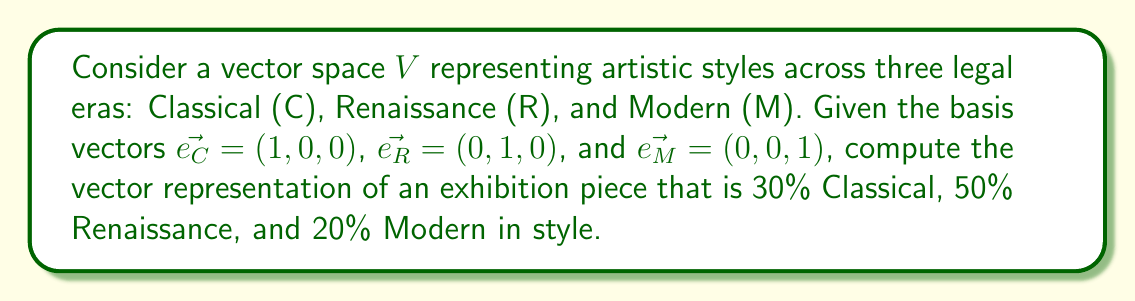Provide a solution to this math problem. To solve this problem, we'll follow these steps:

1) First, recall that in a vector space, we can represent any vector as a linear combination of basis vectors. In this case, our basis vectors are:

   $\vec{e_C} = (1,0,0)$ for Classical
   $\vec{e_R} = (0,1,0)$ for Renaissance
   $\vec{e_M} = (0,0,1)$ for Modern

2) The exhibition piece is described as being 30% Classical, 50% Renaissance, and 20% Modern. We can represent these percentages as scalar coefficients:

   Classical: 0.3
   Renaissance: 0.5
   Modern: 0.2

3) Now, we can form the linear combination:

   $\vec{v} = 0.3\vec{e_C} + 0.5\vec{e_R} + 0.2\vec{e_M}$

4) Let's substitute the basis vectors:

   $\vec{v} = 0.3(1,0,0) + 0.5(0,1,0) + 0.2(0,0,1)$

5) Multiply each scalar by its corresponding vector:

   $\vec{v} = (0.3,0,0) + (0,0.5,0) + (0,0,0.2)$

6) Add the resulting vectors:

   $\vec{v} = (0.3,0.5,0.2)$

This final vector $(0.3,0.5,0.2)$ represents the exhibition piece in the given vector space of artistic styles across the three legal eras.
Answer: $(0.3,0.5,0.2)$ 